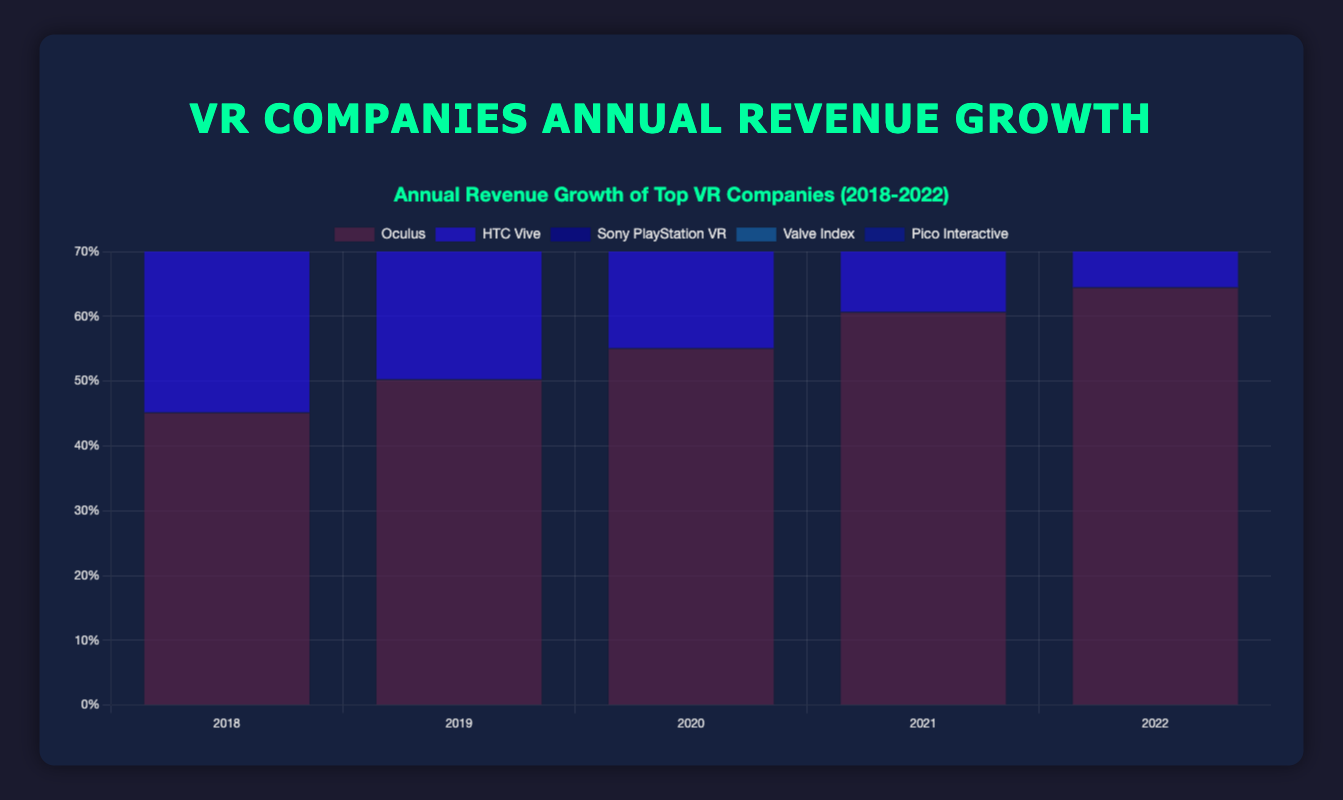Which company had the highest annual revenue growth percentage in 2022? Look for the tallest blue bar in the year 2022. Oculus shows a 64.5% growth, which is the highest among all companies for that year.
Answer: Oculus Which company had the lowest annual revenue growth in 2018? Find the shortest blue bar in the year 2018. Valve Index shows a growth of 29.1%, which is the lowest among all companies for that year.
Answer: Valve Index What is the difference in annual revenue growth percentage between Oculus and HTC Vive in 2022? In 2022, Oculus had an annual revenue growth of 64.5% and HTC Vive had 47.2%. The difference is calculated as 64.5% - 47.2% = 17.3%.
Answer: 17.3% Which company showed consistent growth every year from 2018 to 2022? Evaluate the height of the bars for each company over the years. Oculus, Sony PlayStation VR, and Pico Interactive all show consistently increasing bars, indicating consistent growth.
Answer: Oculus, Sony PlayStation VR, Pico Interactive What was the average annual revenue growth percentage for Sony PlayStation VR across the five years? Sum up the values for each year for Sony PlayStation VR: 34.7% + 37.2% + 40.6% + 44.8% + 49.0% = 206.3%. Then divide by 5 (the number of years): 206.3% / 5 = 41.26%.
Answer: 41.26% How does the growth trend of HTC Vive compare to Valve Index from 2018 to 2022? For both HTC Vive and Valve Index, plot the values over the years and observe the trend. HTC Vive starts at 38.5% and ends at 47.2%, showing an overall upward trend with a dip in 2021. Valve Index starts at 29.1% and ends at 45.3%, showing a consistent upward trend.
Answer: Both showed upward trends, HTC Vive had a slight dip in 2021, Valve Index more consistent How much higher is the annual revenue growth of Oculus in 2020 compared to Pico Interactive in the same year? Oculus had a 55.1% growth in 2020, whereas Pico Interactive had 39.5%. The difference is 55.1% - 39.5% = 15.6%.
Answer: 15.6% Which year did Sony PlayStation VR experience the highest annual revenue growth increase compared to the previous year? Subtract the growth percentage of each year from the previous year for Sony PlayStation VR and find the maximum difference. From 2018 to 2019: 37.2% - 34.7% = 2.5%, from 2019 to 2020: 40.6% - 37.2% = 3.4%, from 2020 to 2021: 44.8% - 40.6% = 4.2%, from 2021 to 2022: 49.0% - 44.8% = 4.2%. The highest increase is from 2020 to 2021 and from 2021 to 2022, both are 4.2%.
Answer: 2020 to 2021, 2021 to 2022 